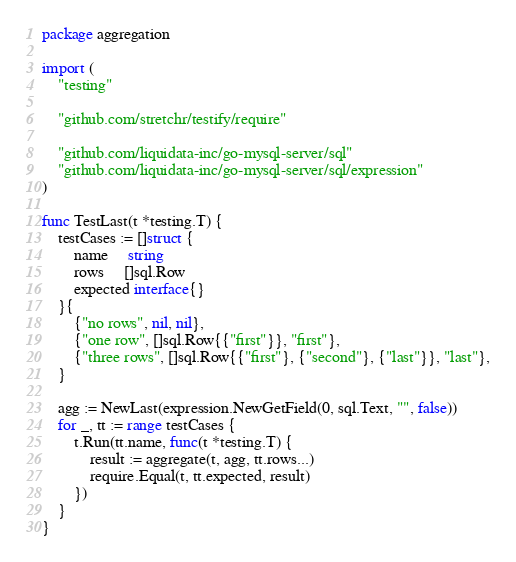Convert code to text. <code><loc_0><loc_0><loc_500><loc_500><_Go_>package aggregation

import (
	"testing"

	"github.com/stretchr/testify/require"

	"github.com/liquidata-inc/go-mysql-server/sql"
	"github.com/liquidata-inc/go-mysql-server/sql/expression"
)

func TestLast(t *testing.T) {
	testCases := []struct {
		name     string
		rows     []sql.Row
		expected interface{}
	}{
		{"no rows", nil, nil},
		{"one row", []sql.Row{{"first"}}, "first"},
		{"three rows", []sql.Row{{"first"}, {"second"}, {"last"}}, "last"},
	}

	agg := NewLast(expression.NewGetField(0, sql.Text, "", false))
	for _, tt := range testCases {
		t.Run(tt.name, func(t *testing.T) {
			result := aggregate(t, agg, tt.rows...)
			require.Equal(t, tt.expected, result)
		})
	}
}
</code> 